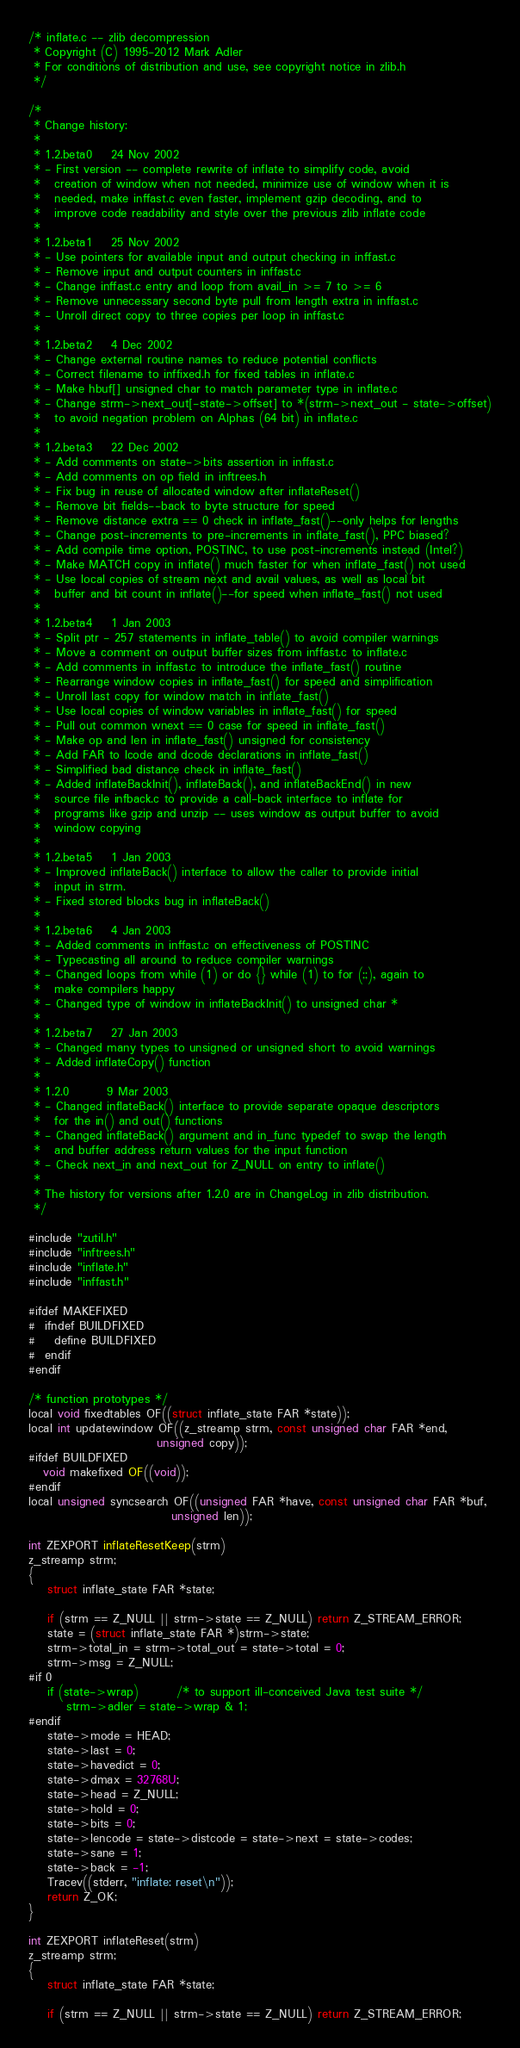<code> <loc_0><loc_0><loc_500><loc_500><_C_>/* inflate.c -- zlib decompression
 * Copyright (C) 1995-2012 Mark Adler
 * For conditions of distribution and use, see copyright notice in zlib.h
 */

/*
 * Change history:
 *
 * 1.2.beta0    24 Nov 2002
 * - First version -- complete rewrite of inflate to simplify code, avoid
 *   creation of window when not needed, minimize use of window when it is
 *   needed, make inffast.c even faster, implement gzip decoding, and to
 *   improve code readability and style over the previous zlib inflate code
 *
 * 1.2.beta1    25 Nov 2002
 * - Use pointers for available input and output checking in inffast.c
 * - Remove input and output counters in inffast.c
 * - Change inffast.c entry and loop from avail_in >= 7 to >= 6
 * - Remove unnecessary second byte pull from length extra in inffast.c
 * - Unroll direct copy to three copies per loop in inffast.c
 *
 * 1.2.beta2    4 Dec 2002
 * - Change external routine names to reduce potential conflicts
 * - Correct filename to inffixed.h for fixed tables in inflate.c
 * - Make hbuf[] unsigned char to match parameter type in inflate.c
 * - Change strm->next_out[-state->offset] to *(strm->next_out - state->offset)
 *   to avoid negation problem on Alphas (64 bit) in inflate.c
 *
 * 1.2.beta3    22 Dec 2002
 * - Add comments on state->bits assertion in inffast.c
 * - Add comments on op field in inftrees.h
 * - Fix bug in reuse of allocated window after inflateReset()
 * - Remove bit fields--back to byte structure for speed
 * - Remove distance extra == 0 check in inflate_fast()--only helps for lengths
 * - Change post-increments to pre-increments in inflate_fast(), PPC biased?
 * - Add compile time option, POSTINC, to use post-increments instead (Intel?)
 * - Make MATCH copy in inflate() much faster for when inflate_fast() not used
 * - Use local copies of stream next and avail values, as well as local bit
 *   buffer and bit count in inflate()--for speed when inflate_fast() not used
 *
 * 1.2.beta4    1 Jan 2003
 * - Split ptr - 257 statements in inflate_table() to avoid compiler warnings
 * - Move a comment on output buffer sizes from inffast.c to inflate.c
 * - Add comments in inffast.c to introduce the inflate_fast() routine
 * - Rearrange window copies in inflate_fast() for speed and simplification
 * - Unroll last copy for window match in inflate_fast()
 * - Use local copies of window variables in inflate_fast() for speed
 * - Pull out common wnext == 0 case for speed in inflate_fast()
 * - Make op and len in inflate_fast() unsigned for consistency
 * - Add FAR to lcode and dcode declarations in inflate_fast()
 * - Simplified bad distance check in inflate_fast()
 * - Added inflateBackInit(), inflateBack(), and inflateBackEnd() in new
 *   source file infback.c to provide a call-back interface to inflate for
 *   programs like gzip and unzip -- uses window as output buffer to avoid
 *   window copying
 *
 * 1.2.beta5    1 Jan 2003
 * - Improved inflateBack() interface to allow the caller to provide initial
 *   input in strm.
 * - Fixed stored blocks bug in inflateBack()
 *
 * 1.2.beta6    4 Jan 2003
 * - Added comments in inffast.c on effectiveness of POSTINC
 * - Typecasting all around to reduce compiler warnings
 * - Changed loops from while (1) or do {} while (1) to for (;;), again to
 *   make compilers happy
 * - Changed type of window in inflateBackInit() to unsigned char *
 *
 * 1.2.beta7    27 Jan 2003
 * - Changed many types to unsigned or unsigned short to avoid warnings
 * - Added inflateCopy() function
 *
 * 1.2.0        9 Mar 2003
 * - Changed inflateBack() interface to provide separate opaque descriptors
 *   for the in() and out() functions
 * - Changed inflateBack() argument and in_func typedef to swap the length
 *   and buffer address return values for the input function
 * - Check next_in and next_out for Z_NULL on entry to inflate()
 *
 * The history for versions after 1.2.0 are in ChangeLog in zlib distribution.
 */

#include "zutil.h"
#include "inftrees.h"
#include "inflate.h"
#include "inffast.h"

#ifdef MAKEFIXED
#  ifndef BUILDFIXED
#    define BUILDFIXED
#  endif
#endif

/* function prototypes */
local void fixedtables OF((struct inflate_state FAR *state));
local int updatewindow OF((z_streamp strm, const unsigned char FAR *end,
                           unsigned copy));
#ifdef BUILDFIXED
   void makefixed OF((void));
#endif
local unsigned syncsearch OF((unsigned FAR *have, const unsigned char FAR *buf,
                              unsigned len));

int ZEXPORT inflateResetKeep(strm)
z_streamp strm;
{
    struct inflate_state FAR *state;

    if (strm == Z_NULL || strm->state == Z_NULL) return Z_STREAM_ERROR;
    state = (struct inflate_state FAR *)strm->state;
    strm->total_in = strm->total_out = state->total = 0;
    strm->msg = Z_NULL;
#if 0
    if (state->wrap)        /* to support ill-conceived Java test suite */
        strm->adler = state->wrap & 1;
#endif
    state->mode = HEAD;
    state->last = 0;
    state->havedict = 0;
    state->dmax = 32768U;
    state->head = Z_NULL;
    state->hold = 0;
    state->bits = 0;
    state->lencode = state->distcode = state->next = state->codes;
    state->sane = 1;
    state->back = -1;
    Tracev((stderr, "inflate: reset\n"));
    return Z_OK;
}

int ZEXPORT inflateReset(strm)
z_streamp strm;
{
    struct inflate_state FAR *state;

    if (strm == Z_NULL || strm->state == Z_NULL) return Z_STREAM_ERROR;</code> 